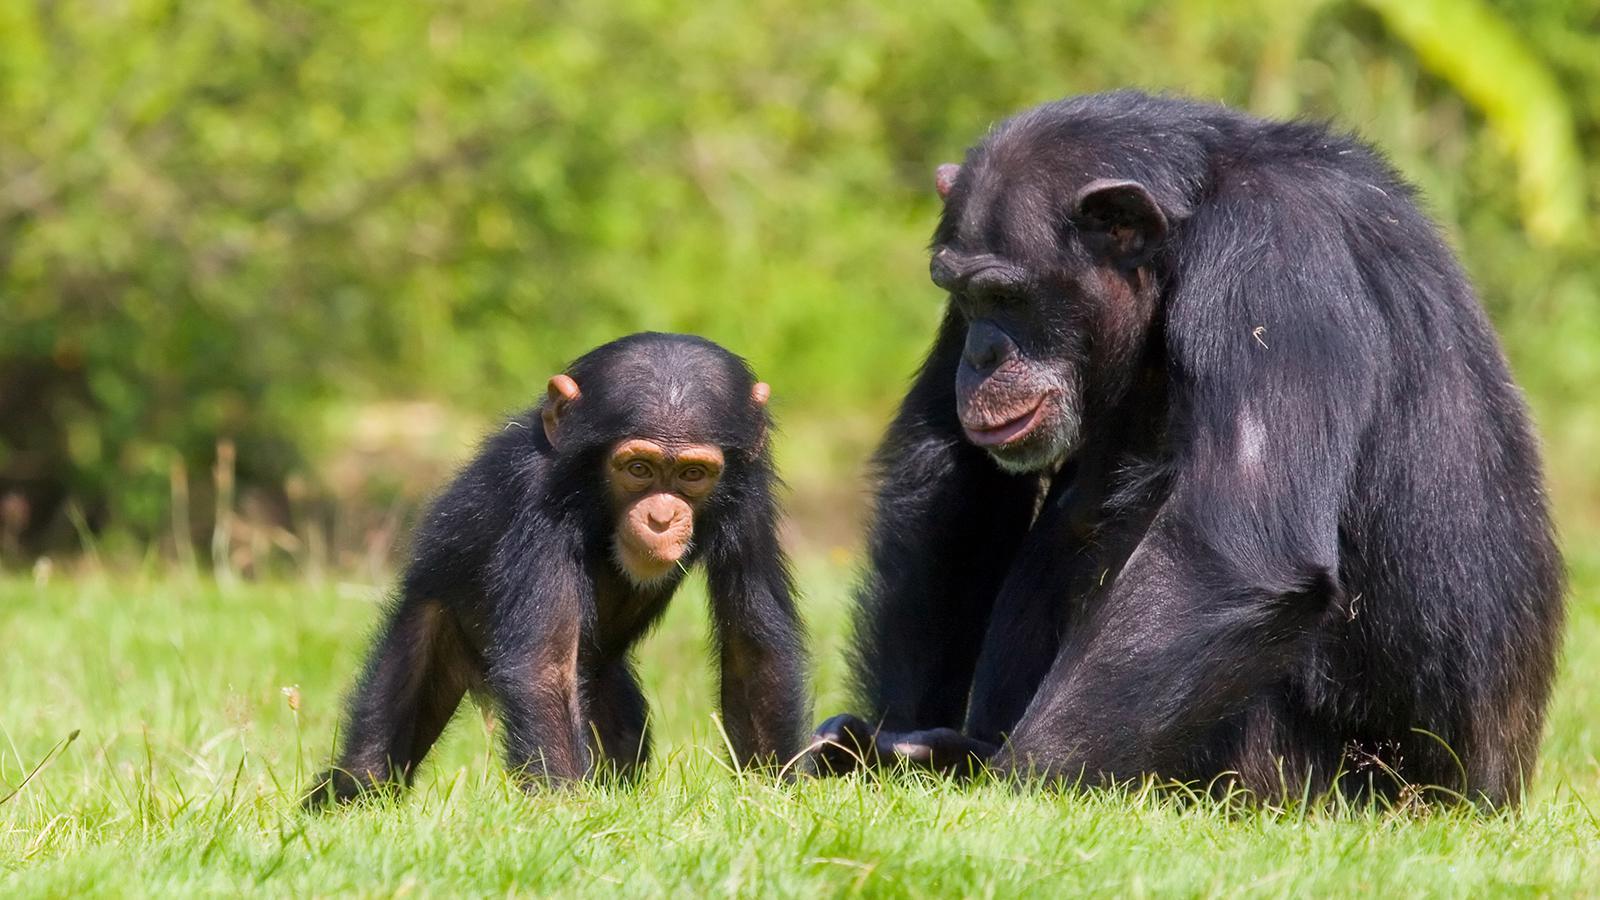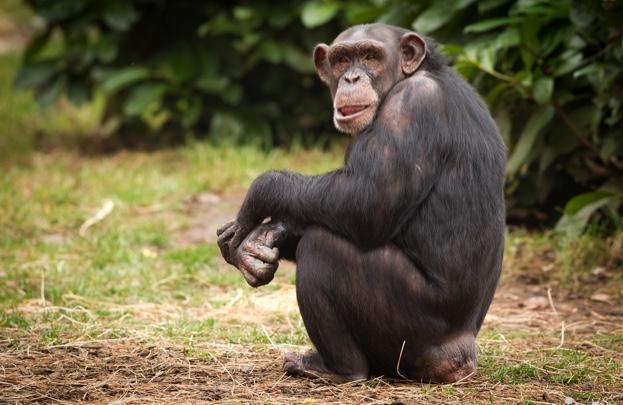The first image is the image on the left, the second image is the image on the right. Examine the images to the left and right. Is the description "An image includes a camera-facing chimp with a wide-open mouth showing at least one row of teeth." accurate? Answer yes or no. No. The first image is the image on the left, the second image is the image on the right. Assess this claim about the two images: "The is one monkey in the image on the right.". Correct or not? Answer yes or no. Yes. The first image is the image on the left, the second image is the image on the right. Evaluate the accuracy of this statement regarding the images: "One animal in the image on the left is baring its teeth.". Is it true? Answer yes or no. No. 